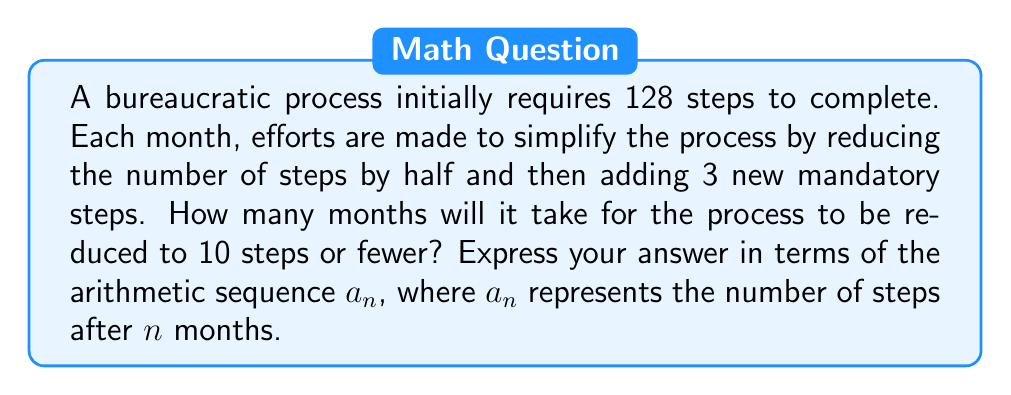Can you answer this question? Let's approach this step-by-step:

1) We start with 128 steps. Let's define our sequence $a_n$:

   $a_0 = 128$ (initial number of steps)

2) For each subsequent month, we halve the previous number of steps and add 3:

   $a_n = \frac{a_{n-1}}{2} + 3$

3) Let's calculate the first few terms:

   $a_1 = \frac{128}{2} + 3 = 67$
   $a_2 = \frac{67}{2} + 3 = 36.5$
   $a_3 = \frac{36.5}{2} + 3 = 21.25$
   $a_4 = \frac{21.25}{2} + 3 = 13.625$
   $a_5 = \frac{13.625}{2} + 3 = 9.8125$

4) We see that after 5 months, the number of steps is less than 10.

5) To express this in terms of the sequence, we're looking for the smallest value of n where:

   $a_n \leq 10$

6) Given the persona's dislike for bureaucracy, this sequence represents a satisfying simplification process, with the answer being the 5th term of the sequence.
Answer: $a_5$ 